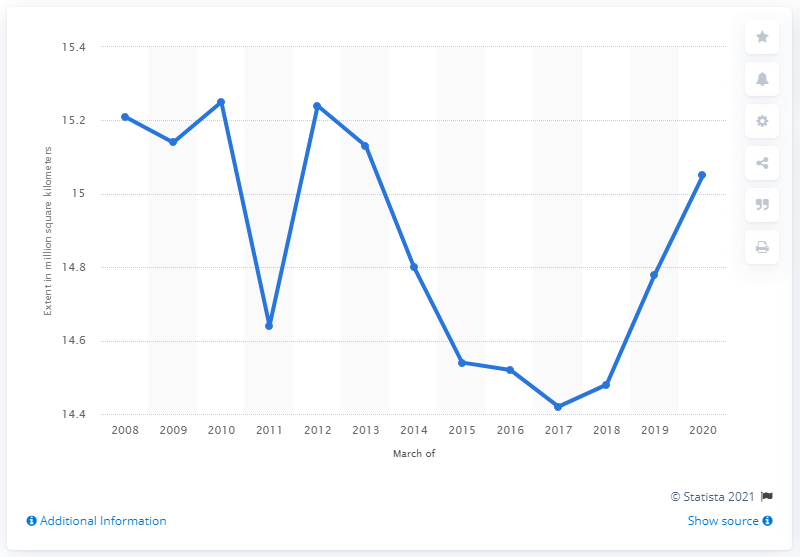Indicate a few pertinent items in this graphic. The maximum extent of Arctic sea ice on March 5, 2020, was 15.05. 